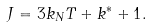<formula> <loc_0><loc_0><loc_500><loc_500>J = 3 k _ { N } T + k ^ { * } + 1 .</formula> 